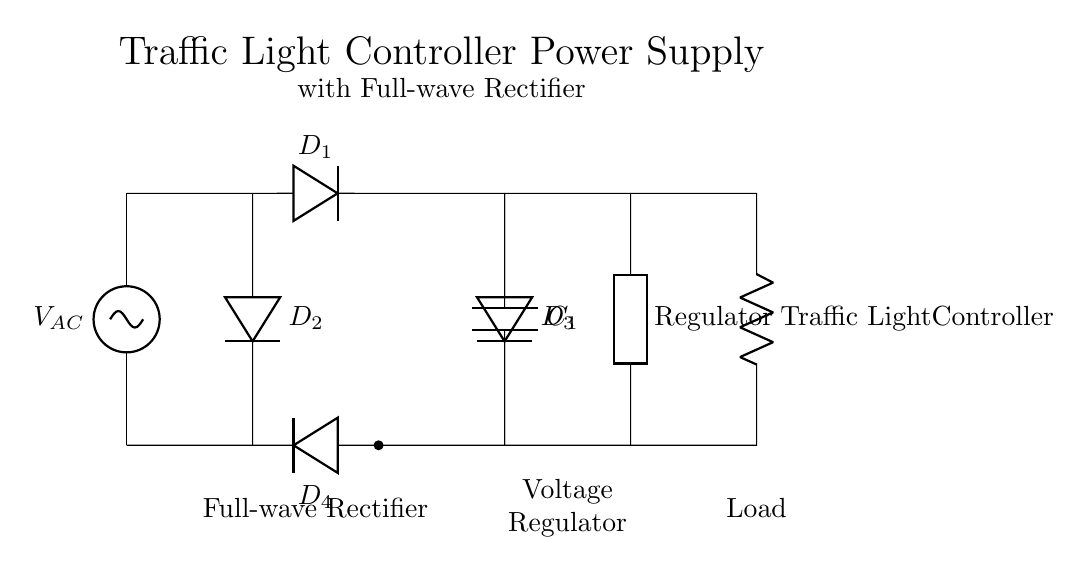What type of rectifier is shown in the circuit? The circuit displays a full-wave rectifier, which is indicated by the configuration of the diodes connecting both halves of the AC waveform to the output.
Answer: full-wave rectifier How many diodes are used in the rectifier? The diagram shows four diodes (D1, D2, D3, and D4) connected in a specific arrangement that allows for full-wave rectification.
Answer: four What is the purpose of the capacitor in this circuit? The capacitor (C1) smooths out the rectified voltage by charging and discharging, which helps to reduce voltage ripples and provide a more consistent DC output.
Answer: smoothing What does the voltage regulator do in this circuit? The voltage regulator conditions the DC output from the rectifier to maintain a steady voltage level, even when the input voltage varies or the load changes.
Answer: maintain voltage What type of load does the circuit power? The load powered by this circuit is specifically labeled as a traffic light controller, which indicates that it operates traffic lights.
Answer: traffic light controller Why is it important to use a full-wave rectifier for this application? A full-wave rectifier increases the efficiency of power conversion from AC to DC by utilizing both halves of the AC cycle, resulting in a higher average output voltage and improved performance for sensitive devices like traffic light controllers.
Answer: efficiency 